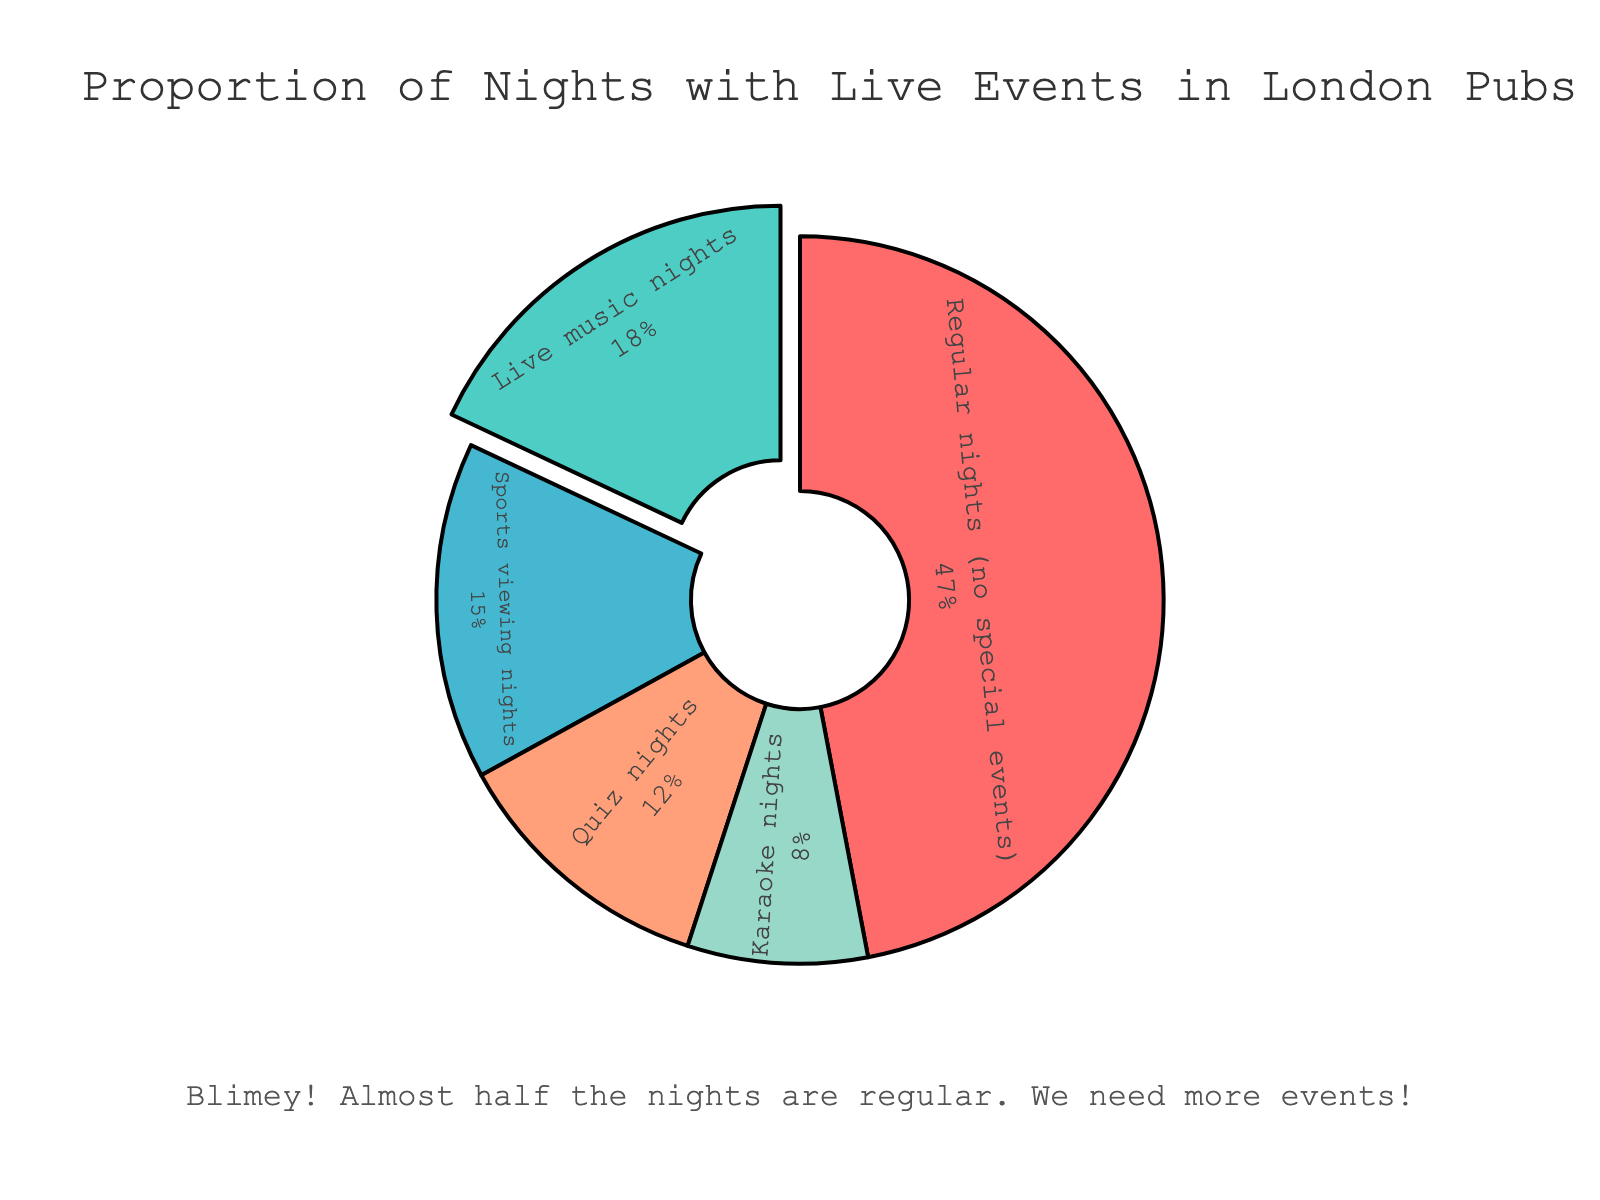Which category has the largest proportion of nights? By looking at the figure, we can see that "Regular nights (no special events)" category occupies almost half of the pie chart, indicating it has the largest proportion.
Answer: Regular nights (no special events) Which categories have a proportion of nights greater than 10%? From the pie chart, we observe that "Live music nights", "Quiz nights", and "Sports viewing nights" each have a proportion greater than 10%.
Answer: Live music nights, Quiz nights, Sports viewing nights What's the total percentage of nights with any type of special event? Sum the percentages of all special event categories: Live music nights (18%) + Quiz nights (12%) + Karaoke nights (8%) + Sports viewing nights (15%) = 53%. This indicates the overall proportion of nights with special events.
Answer: 53% How do "Karaoke nights" compare to "Sports viewing nights" in terms of proportion? According to the pie chart, "Karaoke nights" have a smaller proportion (8%) compared to "Sports viewing nights" (15%). Thus, "Sports viewing nights" have nearly double the proportion of "Karaoke nights".
Answer: Karaoke nights have a smaller proportion than Sports viewing nights Which category is visually represented by the blue color? Observing the colors in the chart, the blue segment represents the "Live music nights" category.
Answer: Live music nights What is the percentage difference between "Live music nights" and "Regular nights"? We calculate the difference between the percentages for these categories: Regular nights (47%) - Live music nights (18%) = 29%.
Answer: 29% Which section of the chart is specifically pulled out? Examining the figure, the section that is pulled out from the rest of the chart highlights the "Live music nights" category.
Answer: Live music nights How many categories have a lower proportion than "Sports viewing nights"? The figure shows that "Live music nights," "Regular nights," and "Quiz nights" have either equal or higher proportions. Hence, "Karaoke nights" (8%) are the only category with a lower proportion than "Sports viewing nights" (15%).
Answer: 1 category (Karaoke nights) What message is conveyed by the annotation added to the chart? The annotation says, "Blimey! Almost half the nights are regular. We need more events!" This emphasizes that a significant portion of nights are uneventful regular nights, suggesting a need for more special events to attract customers.
Answer: Nearly half the nights are regular; more events might be needed 